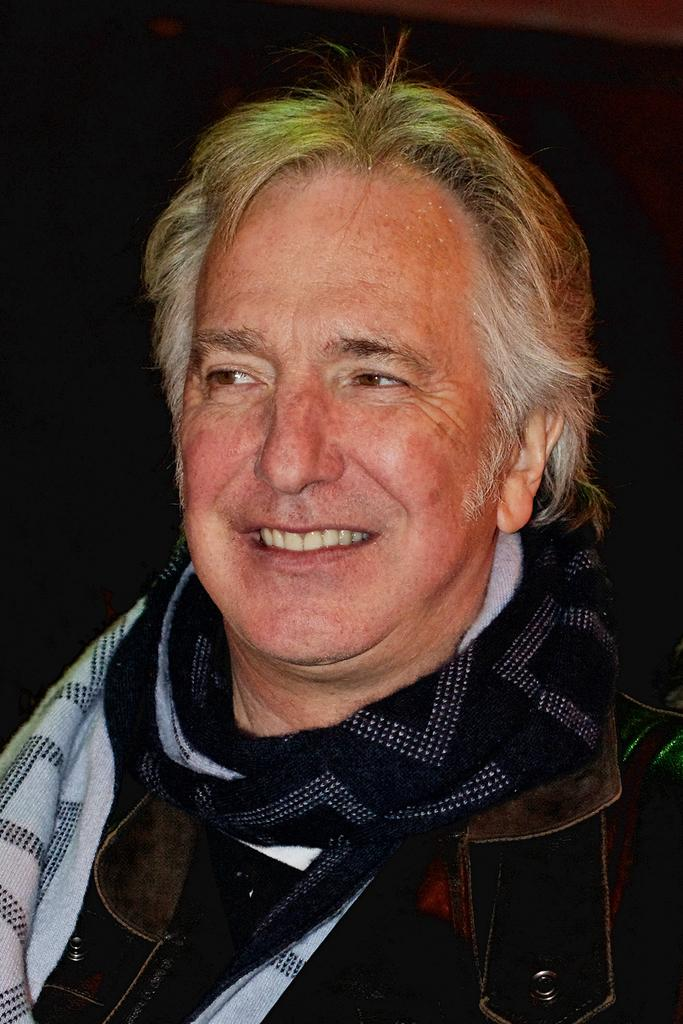Who is the main subject in the image? There is a man in the center of the image. What is the man wearing in the image? The man is wearing a scarf and a coat. What is the man's facial expression in the image? The man is smiling. Can you see a boat in the image? No, there is no boat present in the image. Is there a giraffe standing next to the man in the image? No, there is no giraffe present in the image. 